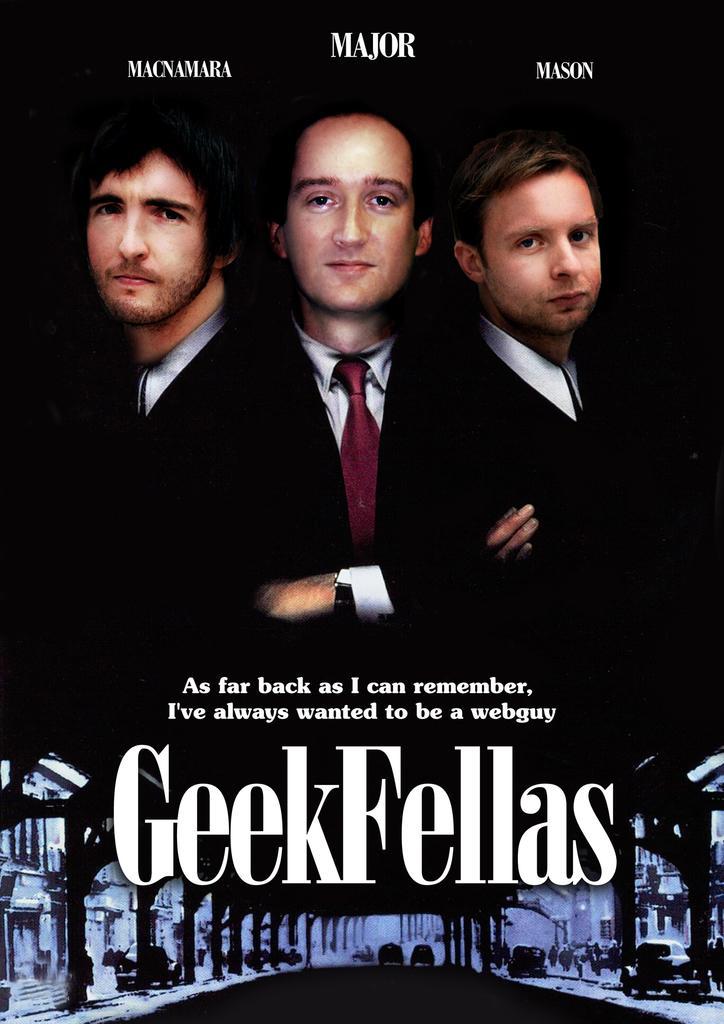Please provide a concise description of this image. In this image we can see a poster with text and images. 